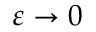<formula> <loc_0><loc_0><loc_500><loc_500>\varepsilon \to 0</formula> 